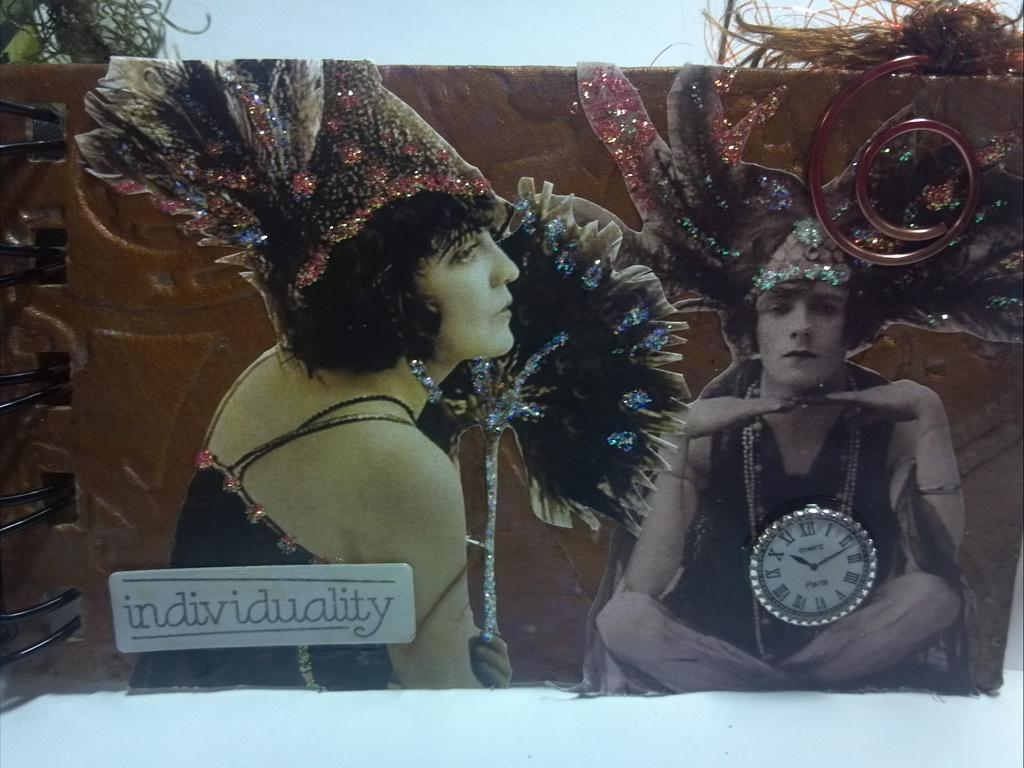<image>
Describe the image concisely. A picture of two people in hats says "individuality." 